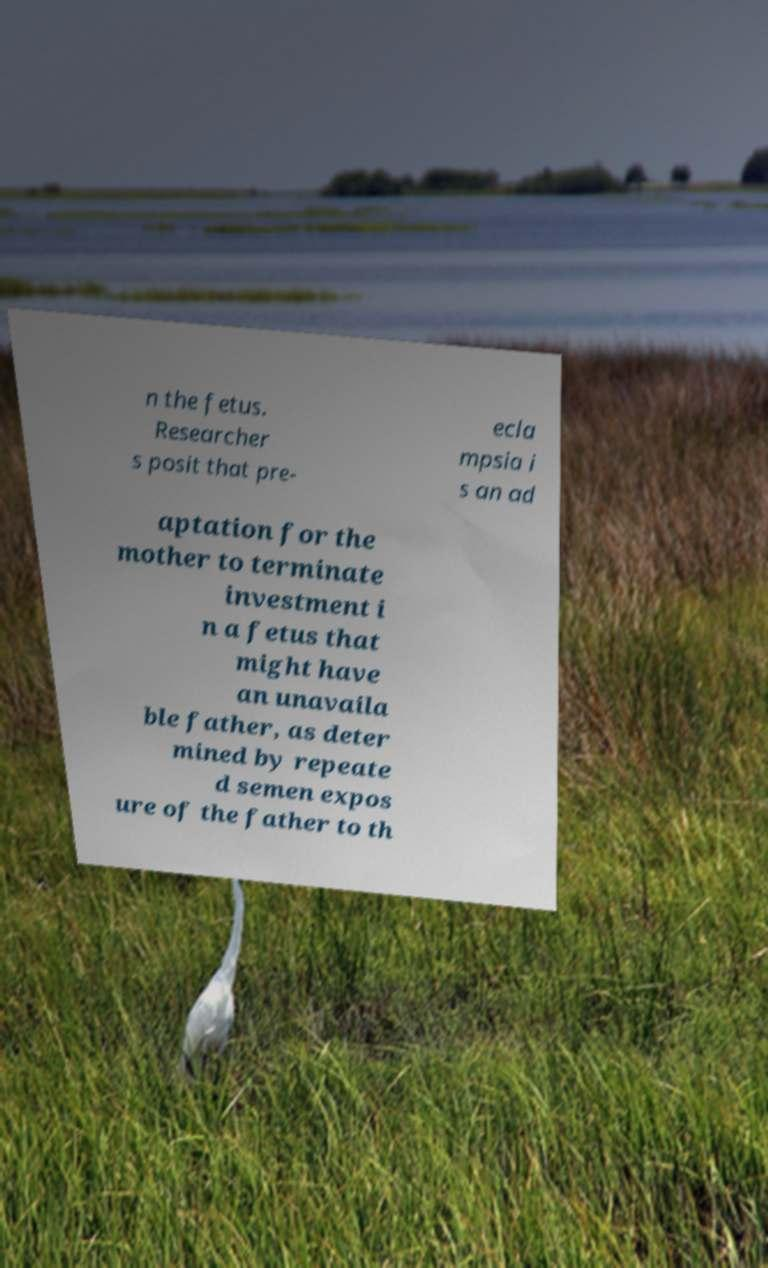There's text embedded in this image that I need extracted. Can you transcribe it verbatim? n the fetus. Researcher s posit that pre- ecla mpsia i s an ad aptation for the mother to terminate investment i n a fetus that might have an unavaila ble father, as deter mined by repeate d semen expos ure of the father to th 